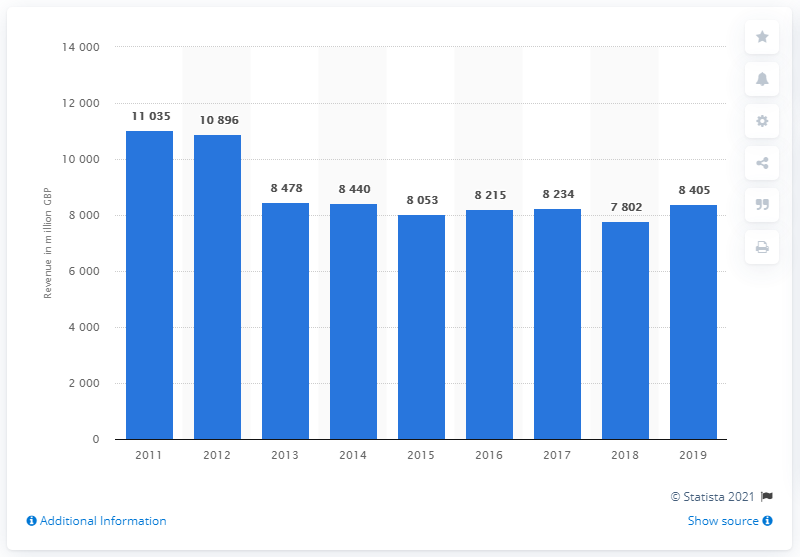Point out several critical features in this image. In 2019, Balfour Beatty generated underlying revenues of approximately £8,405. 